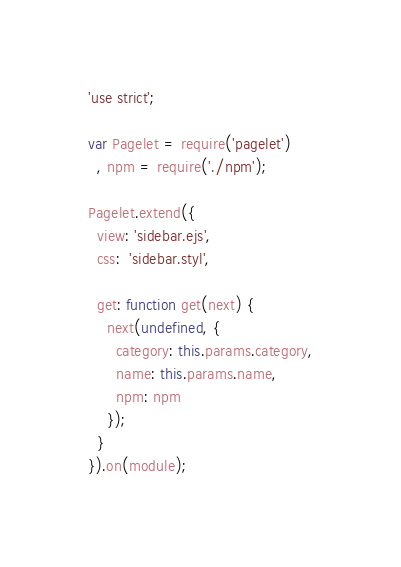<code> <loc_0><loc_0><loc_500><loc_500><_JavaScript_>'use strict';

var Pagelet = require('pagelet')
  , npm = require('./npm');

Pagelet.extend({
  view: 'sidebar.ejs',
  css:  'sidebar.styl',

  get: function get(next) {
    next(undefined, {
      category: this.params.category,
      name: this.params.name,
      npm: npm
    });
  }
}).on(module);
</code> 